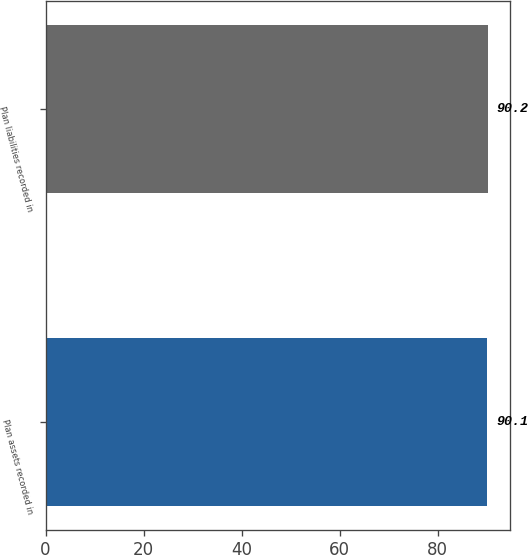<chart> <loc_0><loc_0><loc_500><loc_500><bar_chart><fcel>Plan assets recorded in<fcel>Plan liabilities recorded in<nl><fcel>90.1<fcel>90.2<nl></chart> 